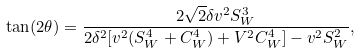<formula> <loc_0><loc_0><loc_500><loc_500>\tan ( 2 \theta ) = \frac { 2 \sqrt { 2 } \delta v ^ { 2 } S ^ { 3 } _ { W } } { 2 \delta ^ { 2 } [ v ^ { 2 } ( S ^ { 4 } _ { W } + C ^ { 4 } _ { W } ) + V ^ { 2 } C ^ { 4 } _ { W } ] - v ^ { 2 } S ^ { 2 } _ { W } } ,</formula> 